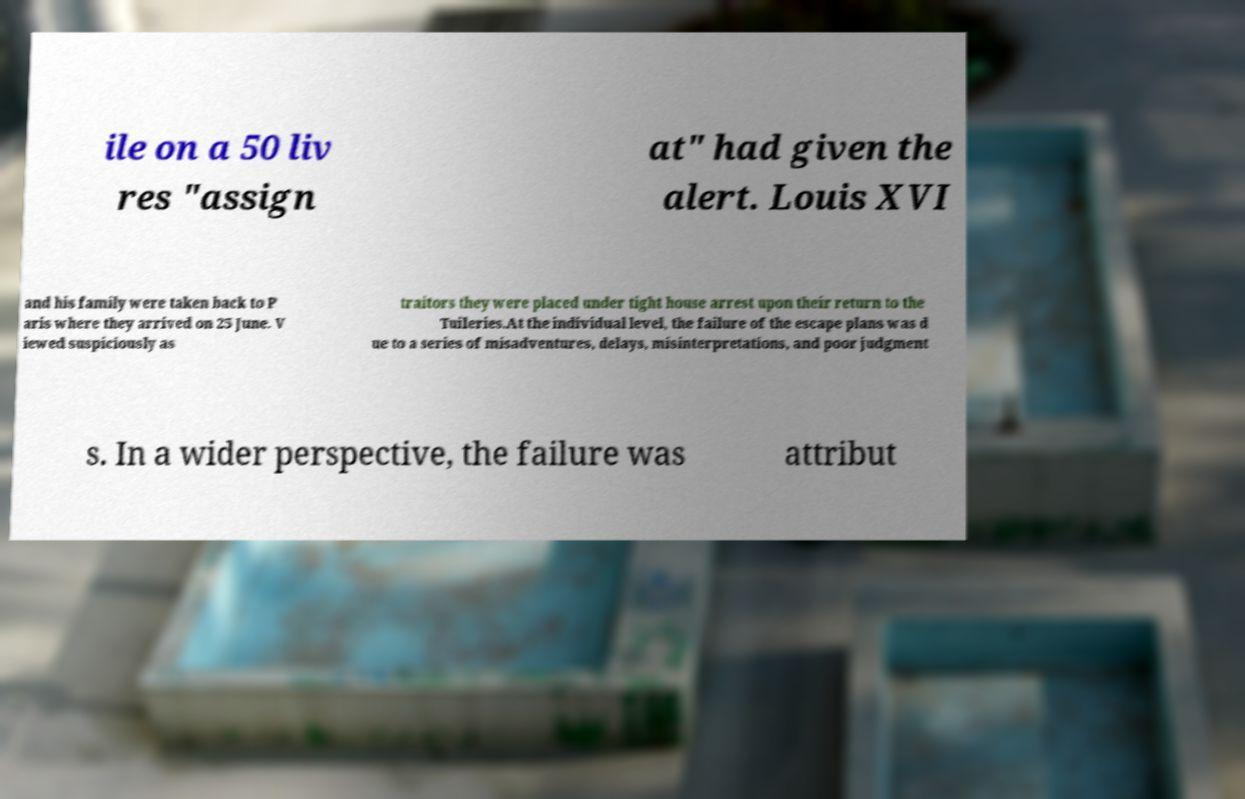Could you extract and type out the text from this image? ile on a 50 liv res "assign at" had given the alert. Louis XVI and his family were taken back to P aris where they arrived on 25 June. V iewed suspiciously as traitors they were placed under tight house arrest upon their return to the Tuileries.At the individual level, the failure of the escape plans was d ue to a series of misadventures, delays, misinterpretations, and poor judgment s. In a wider perspective, the failure was attribut 